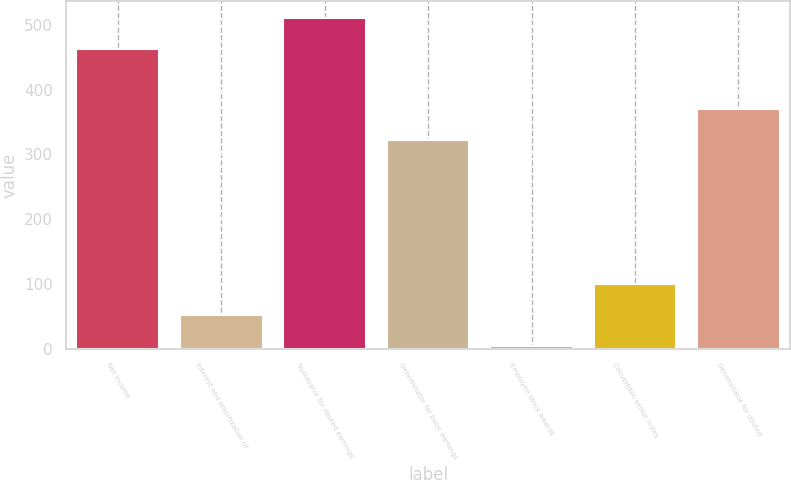Convert chart to OTSL. <chart><loc_0><loc_0><loc_500><loc_500><bar_chart><fcel>Net income<fcel>Interest and amortization of<fcel>Numerator for diluted earnings<fcel>Denominator for basic earnings<fcel>Employee stock awards<fcel>Convertible senior notes<fcel>Denominator for diluted<nl><fcel>462.7<fcel>52.44<fcel>510.94<fcel>322.1<fcel>4.2<fcel>100.68<fcel>370.34<nl></chart> 